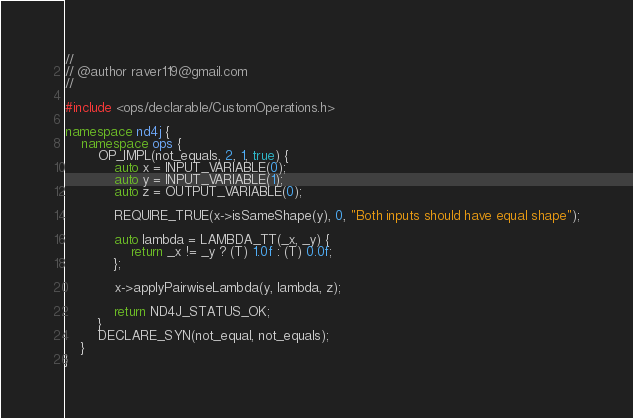Convert code to text. <code><loc_0><loc_0><loc_500><loc_500><_C++_>//
// @author raver119@gmail.com
//

#include <ops/declarable/CustomOperations.h>

namespace nd4j {
    namespace ops {
        OP_IMPL(not_equals, 2, 1, true) {
            auto x = INPUT_VARIABLE(0);
            auto y = INPUT_VARIABLE(1);
            auto z = OUTPUT_VARIABLE(0);

            REQUIRE_TRUE(x->isSameShape(y), 0, "Both inputs should have equal shape");

            auto lambda = LAMBDA_TT(_x, _y) {
                return _x != _y ? (T) 1.0f : (T) 0.0f;
            };

            x->applyPairwiseLambda(y, lambda, z);

            return ND4J_STATUS_OK;
        }
        DECLARE_SYN(not_equal, not_equals);
    }
}</code> 